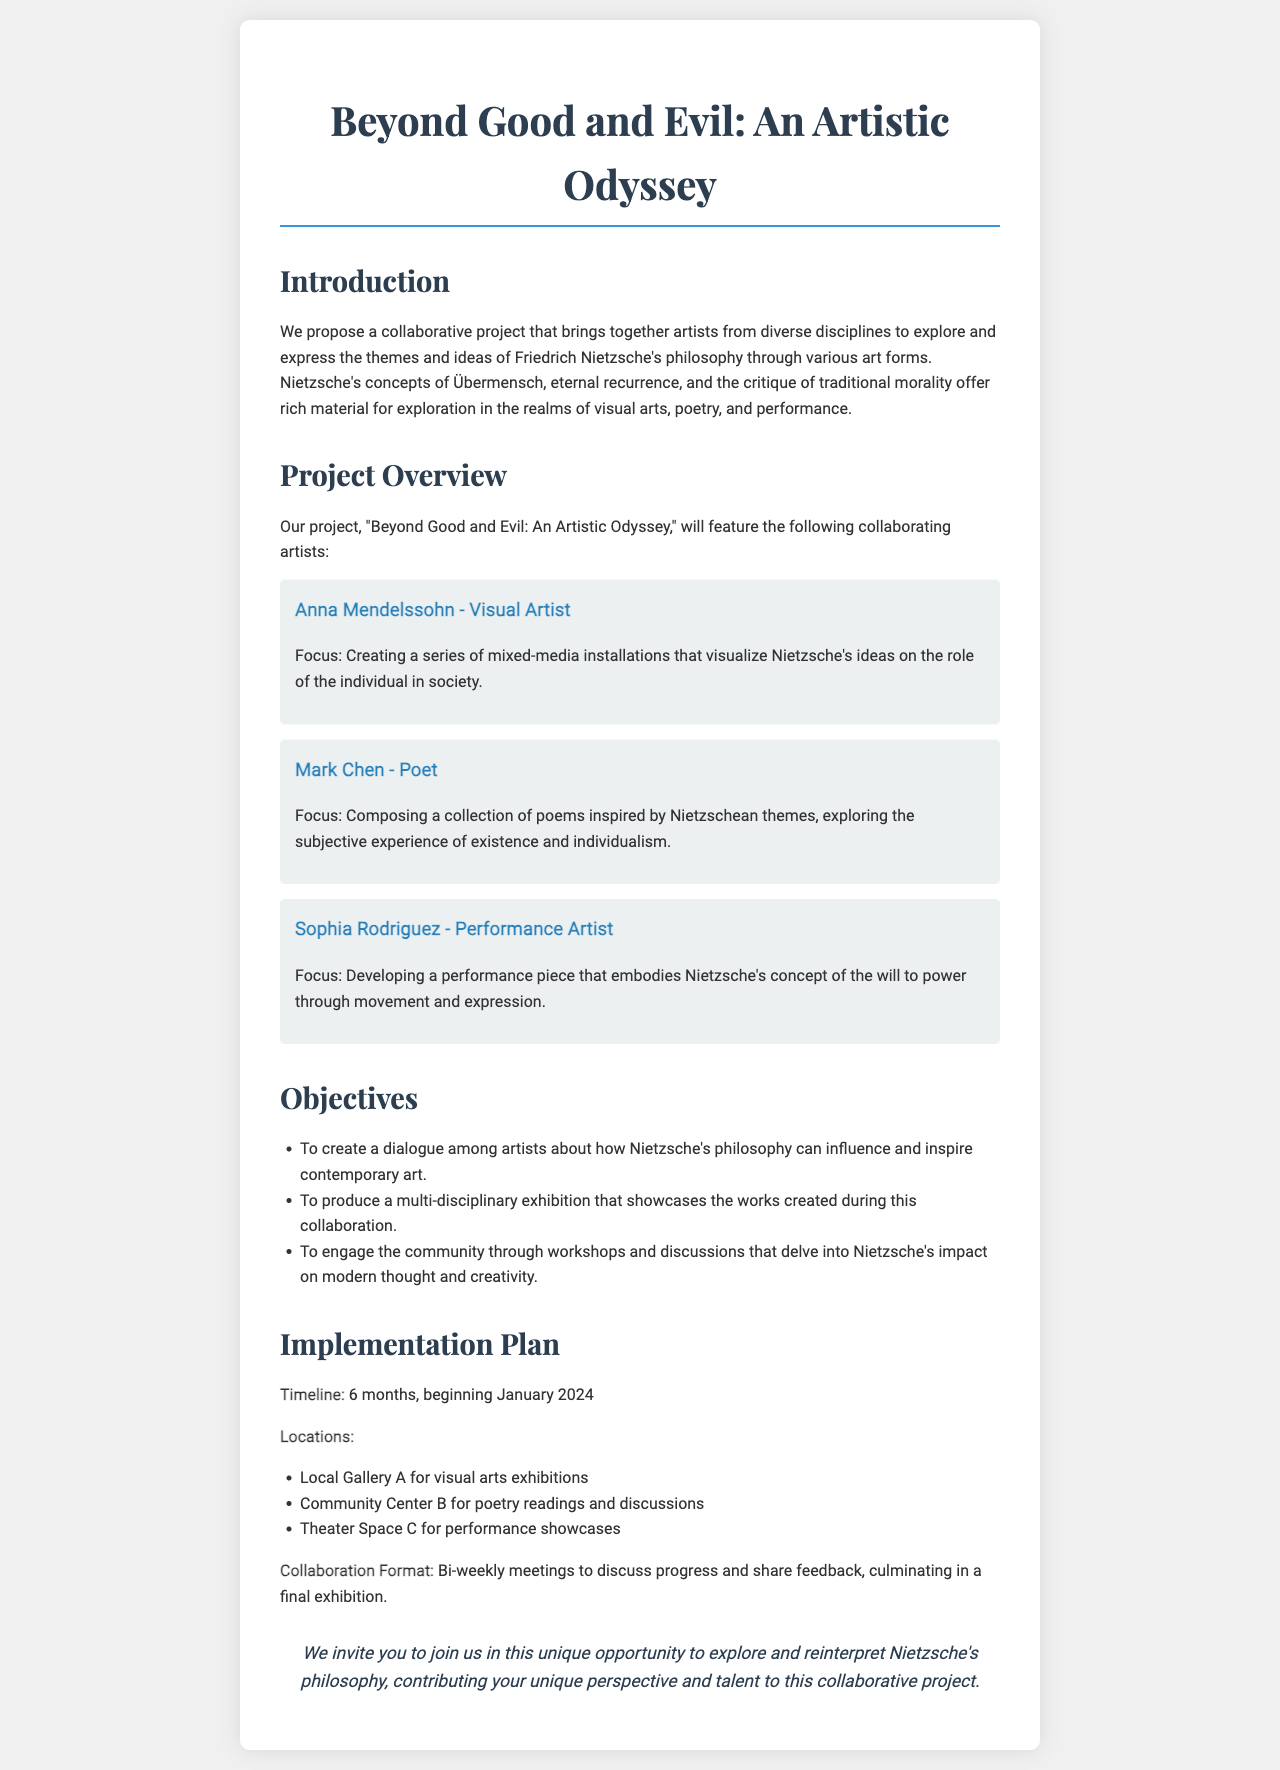What is the title of the project? The title of the project is mentioned in the document as "Beyond Good and Evil: An Artistic Odyssey."
Answer: Beyond Good and Evil: An Artistic Odyssey Who is the visual artist involved in the project? The document lists Anna Mendelssohn as the visual artist contributing to the project.
Answer: Anna Mendelssohn What is the main philosophy being explored? The document explicitly states that the collaboration explores Friedrich Nietzsche's philosophy.
Answer: Nietzsche's philosophy How long will the project last? The implementation plan specifies that the project will last for 6 months.
Answer: 6 months What will be discussed in the bi-weekly meetings? The bi-weekly meetings will focus on discussing progress and sharing feedback as part of the collaboration.
Answer: Progress and feedback What is one of the objectives of the project? The document lists creating a dialogue among artists about Nietzsche's philosophy as one of its objectives.
Answer: Creating a dialogue Where will the poetry readings be held? The poetry readings are planned to be held at Community Center B according to the locations specified in the document.
Answer: Community Center B What type of performance is being developed? The document indicates that a performance piece embodying Nietzsche's concept of the will to power is being developed.
Answer: Performance piece 